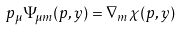<formula> <loc_0><loc_0><loc_500><loc_500>p _ { \mu } \Psi _ { \mu m } ( p , y ) = \nabla _ { m } \chi ( p , y )</formula> 